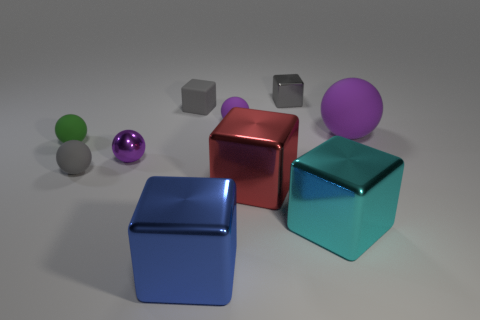Can you describe the lighting in the scene and how it affects the appearance of the objects? The lighting in the scene is soft and appears to be coming from above, casting gentle shadows beneath the objects. This overhead lighting enhances the three-dimensionality of each object by creating light edges and subtle gradients across their surfaces. The reflective objects like the purple sphere, the red cube, and the blue cubes are particularly influenced by this lighting, as it creates highlights that give them a lustrous look, while the matte objects absorb more light, hence they don't have prominent highlights or reflections.  How do the shadows contribute to the perception of depth in the scene? The shadows in the image play a crucial role in conveying depth and dimension. They lie directly underneath and to the side of the objects, slightly stretched, which implies that the light source is not directly overhead but somewhat angled. The size, direction, and softness of the shadows help to anchor the objects in space, giving us visual cues about their relative positions and the distances between them. This in turn helps our brain interpret the three-dimensional layout of the scene. 